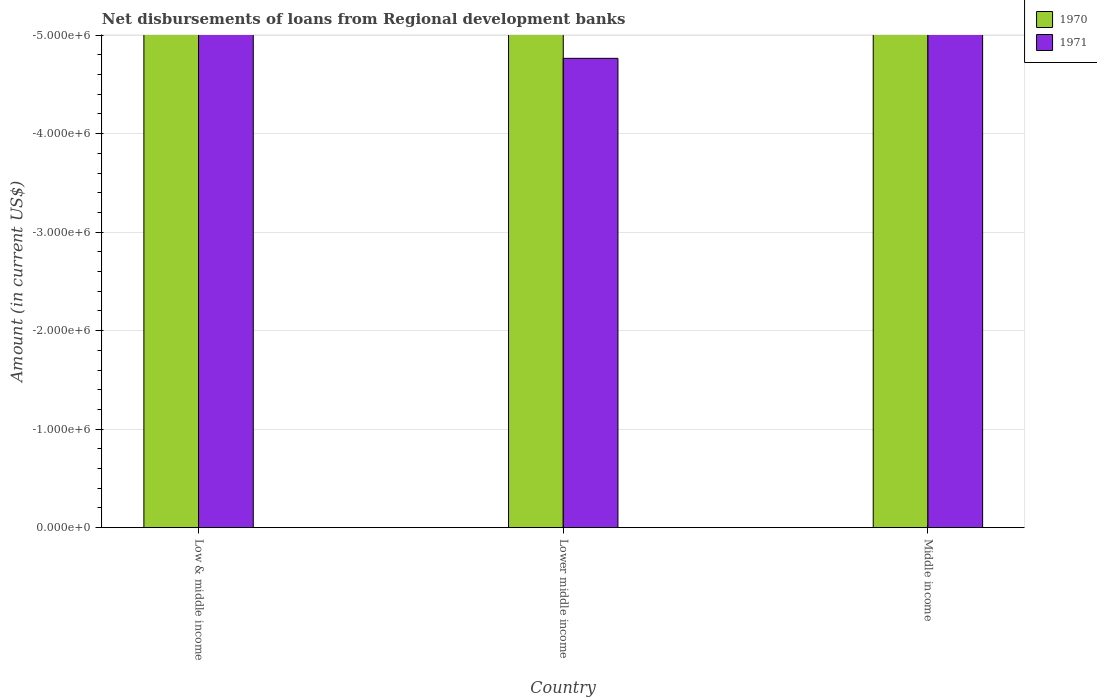How many different coloured bars are there?
Provide a short and direct response. 0. Are the number of bars on each tick of the X-axis equal?
Your answer should be compact. Yes. In how many cases, is the number of bars for a given country not equal to the number of legend labels?
Give a very brief answer. 3. What is the amount of disbursements of loans from regional development banks in 1971 in Lower middle income?
Keep it short and to the point. 0. Across all countries, what is the minimum amount of disbursements of loans from regional development banks in 1970?
Give a very brief answer. 0. What is the average amount of disbursements of loans from regional development banks in 1970 per country?
Your answer should be very brief. 0. In how many countries, is the amount of disbursements of loans from regional development banks in 1970 greater than the average amount of disbursements of loans from regional development banks in 1970 taken over all countries?
Your answer should be compact. 0. Are all the bars in the graph horizontal?
Offer a terse response. No. What is the difference between two consecutive major ticks on the Y-axis?
Offer a terse response. 1.00e+06. Are the values on the major ticks of Y-axis written in scientific E-notation?
Your answer should be compact. Yes. Where does the legend appear in the graph?
Ensure brevity in your answer.  Top right. How many legend labels are there?
Provide a short and direct response. 2. What is the title of the graph?
Keep it short and to the point. Net disbursements of loans from Regional development banks. Does "1997" appear as one of the legend labels in the graph?
Your response must be concise. No. What is the label or title of the X-axis?
Ensure brevity in your answer.  Country. What is the Amount (in current US$) of 1971 in Lower middle income?
Give a very brief answer. 0. What is the Amount (in current US$) in 1970 in Middle income?
Your answer should be very brief. 0. What is the total Amount (in current US$) in 1971 in the graph?
Keep it short and to the point. 0. What is the average Amount (in current US$) in 1970 per country?
Offer a terse response. 0. 